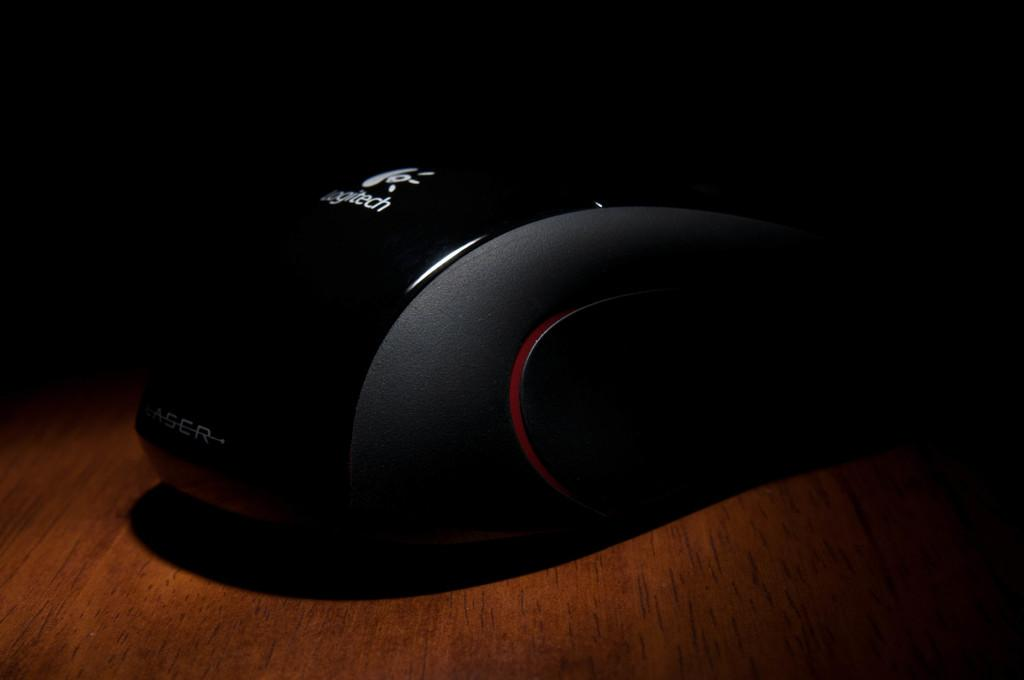Where was the image taken? The image was taken indoors. What is located at the bottom of the image? There is a table at the bottom of the image. How would you describe the lighting in the image? The background of the image is dark. What can be seen in the middle of the image, on the table? There is a mouse in the middle of the image, on the table. What type of distribution is being carried out in the image? There is no distribution being carried out in the image; it features a mouse on a table. What is the fork used for in the image? There is no fork present in the image. 